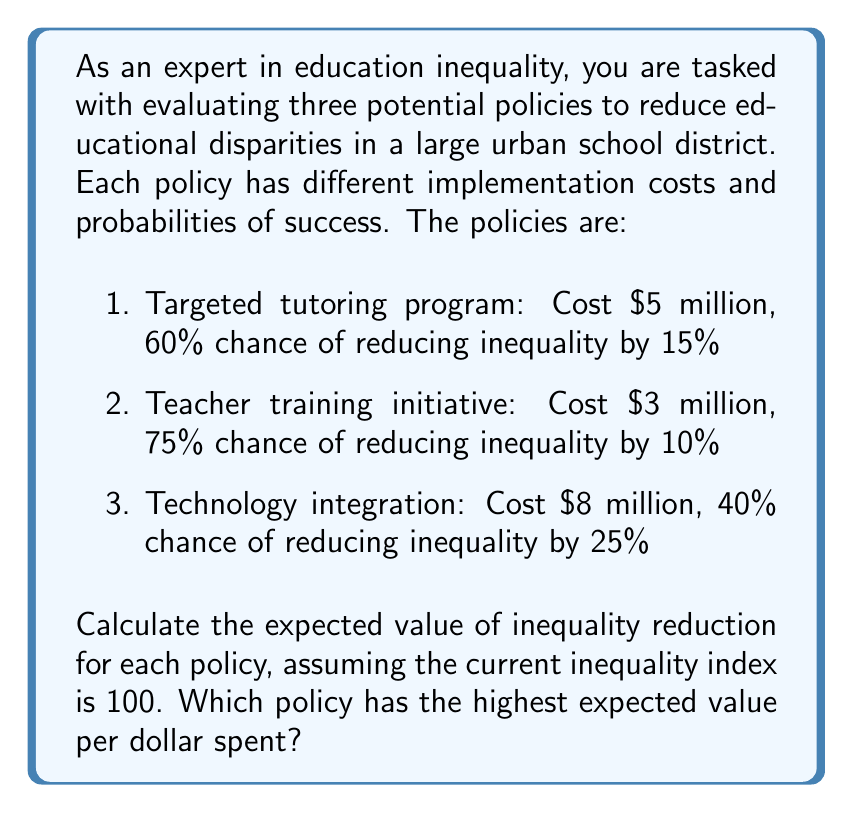Teach me how to tackle this problem. To solve this problem, we need to calculate the expected value of inequality reduction for each policy and then determine which policy provides the highest expected value per dollar spent.

1. Targeted tutoring program:
   - Probability of success: 60% = 0.6
   - Inequality reduction if successful: 15% of 100 = 15
   - Expected value: $EV_1 = 0.6 \times 15 + 0.4 \times 0 = 9$
   - Cost: $5 million
   - Expected value per dollar: $\frac{9}{5,000,000} = 1.8 \times 10^{-6}$

2. Teacher training initiative:
   - Probability of success: 75% = 0.75
   - Inequality reduction if successful: 10% of 100 = 10
   - Expected value: $EV_2 = 0.75 \times 10 + 0.25 \times 0 = 7.5$
   - Cost: $3 million
   - Expected value per dollar: $\frac{7.5}{3,000,000} = 2.5 \times 10^{-6}$

3. Technology integration:
   - Probability of success: 40% = 0.4
   - Inequality reduction if successful: 25% of 100 = 25
   - Expected value: $EV_3 = 0.4 \times 25 + 0.6 \times 0 = 10$
   - Cost: $8 million
   - Expected value per dollar: $\frac{10}{8,000,000} = 1.25 \times 10^{-6}$

Comparing the expected values per dollar spent:
1. Targeted tutoring: $1.8 \times 10^{-6}$
2. Teacher training: $2.5 \times 10^{-6}$
3. Technology integration: $1.25 \times 10^{-6}$

The teacher training initiative has the highest expected value per dollar spent.
Answer: The teacher training initiative has the highest expected value per dollar spent at $2.5 \times 10^{-6}$ units of inequality reduction per dollar. 